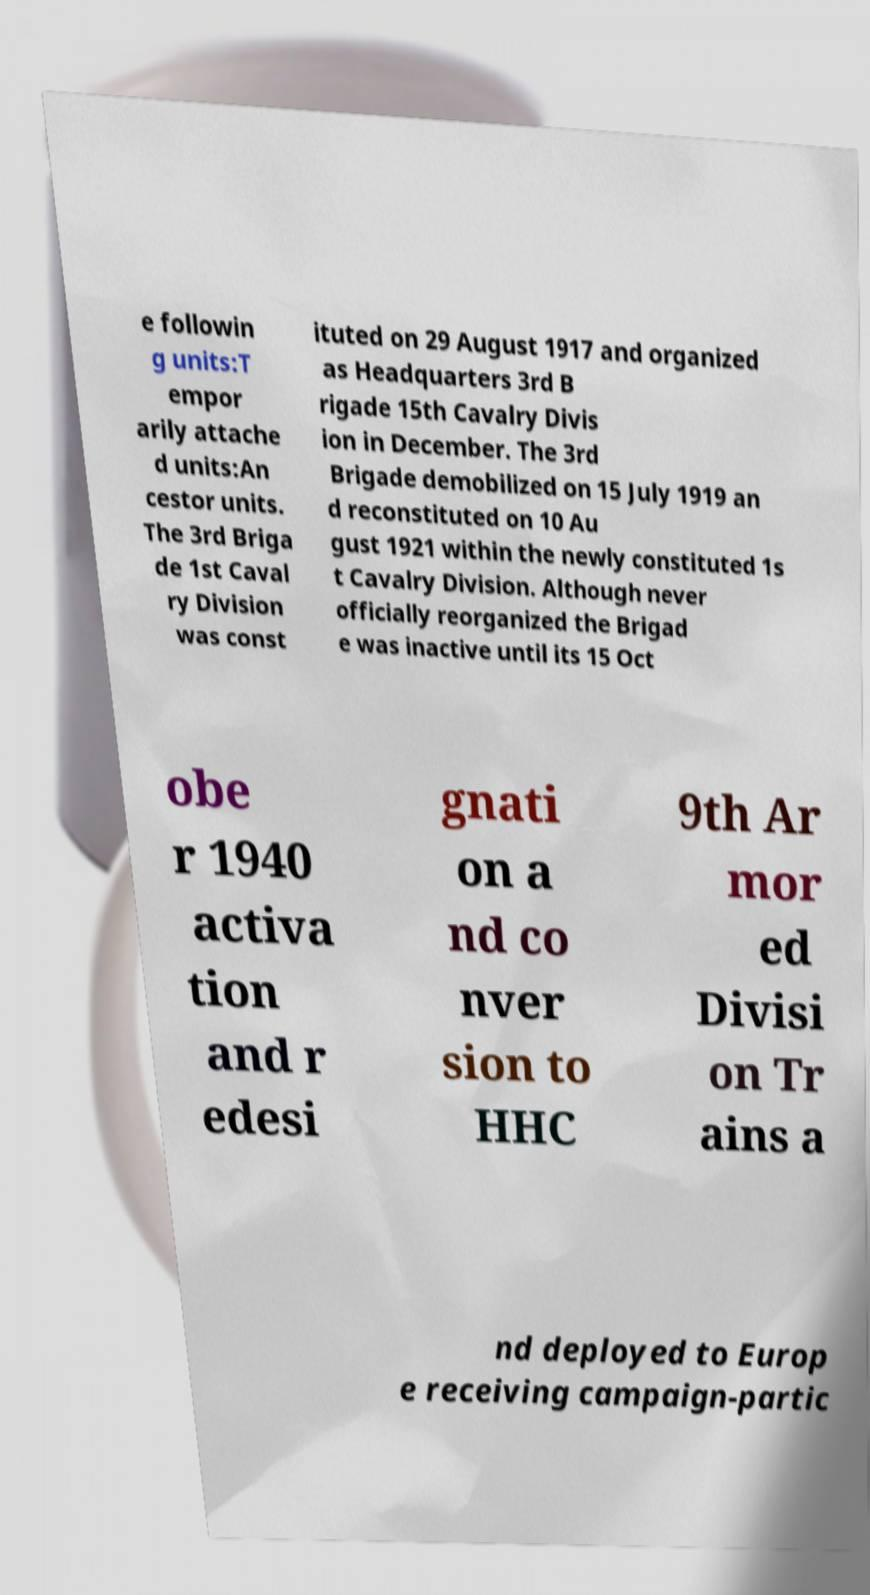For documentation purposes, I need the text within this image transcribed. Could you provide that? e followin g units:T empor arily attache d units:An cestor units. The 3rd Briga de 1st Caval ry Division was const ituted on 29 August 1917 and organized as Headquarters 3rd B rigade 15th Cavalry Divis ion in December. The 3rd Brigade demobilized on 15 July 1919 an d reconstituted on 10 Au gust 1921 within the newly constituted 1s t Cavalry Division. Although never officially reorganized the Brigad e was inactive until its 15 Oct obe r 1940 activa tion and r edesi gnati on a nd co nver sion to HHC 9th Ar mor ed Divisi on Tr ains a nd deployed to Europ e receiving campaign-partic 